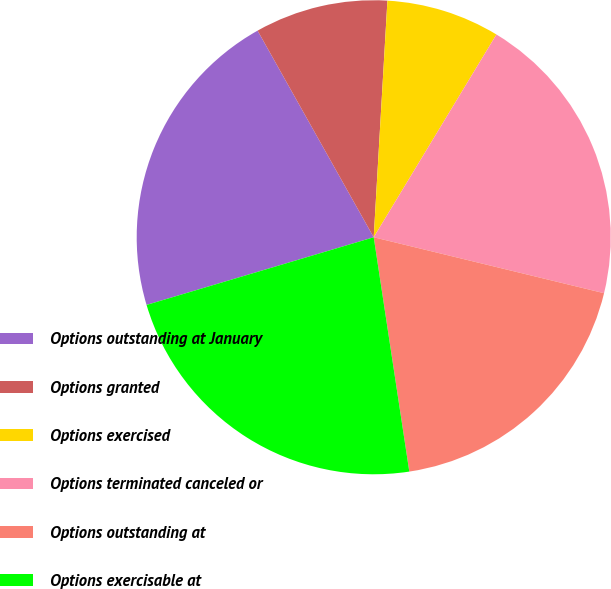Convert chart to OTSL. <chart><loc_0><loc_0><loc_500><loc_500><pie_chart><fcel>Options outstanding at January<fcel>Options granted<fcel>Options exercised<fcel>Options terminated canceled or<fcel>Options outstanding at<fcel>Options exercisable at<nl><fcel>21.46%<fcel>9.07%<fcel>7.74%<fcel>20.13%<fcel>18.81%<fcel>22.79%<nl></chart> 